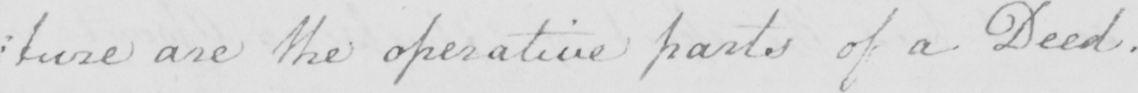Please transcribe the handwritten text in this image. : ture are the operative parts of a Deed . 